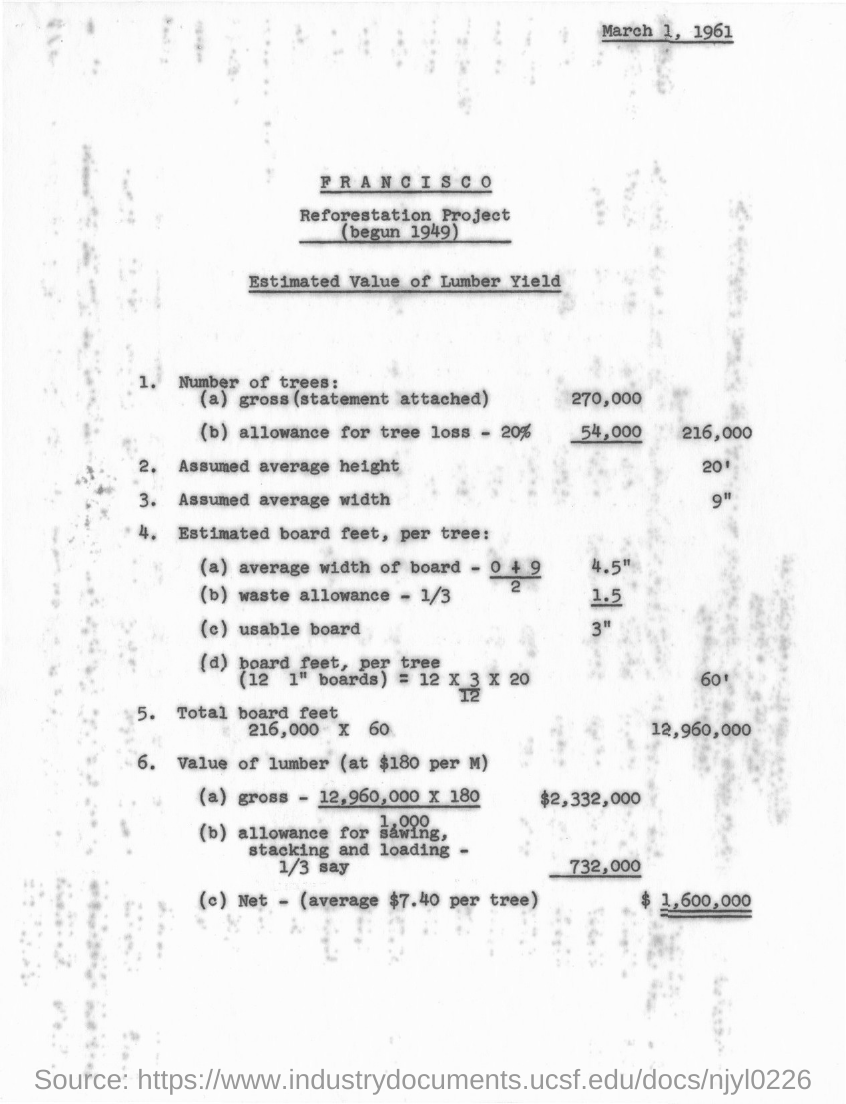When is the document dated?
Offer a very short reply. MARCH 1, 1961. When did the reforestation project begin?
Your answer should be very brief. 1949. What is the assumed average height?
Make the answer very short. 20'. What is the Net value of lumber?
Your answer should be very brief. $ 1,600,000. 